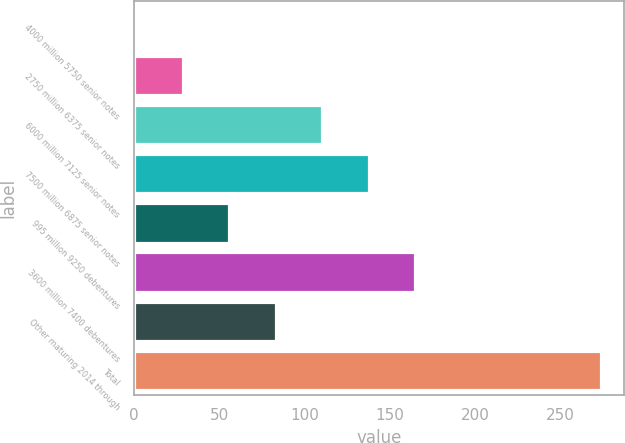Convert chart. <chart><loc_0><loc_0><loc_500><loc_500><bar_chart><fcel>4000 million 5750 senior notes<fcel>2750 million 6375 senior notes<fcel>6000 million 7125 senior notes<fcel>7500 million 6875 senior notes<fcel>995 million 9250 debentures<fcel>3600 million 7400 debentures<fcel>Other maturing 2014 through<fcel>Total<nl><fcel>1.2<fcel>28.48<fcel>110.32<fcel>137.6<fcel>55.76<fcel>164.88<fcel>83.04<fcel>274<nl></chart> 